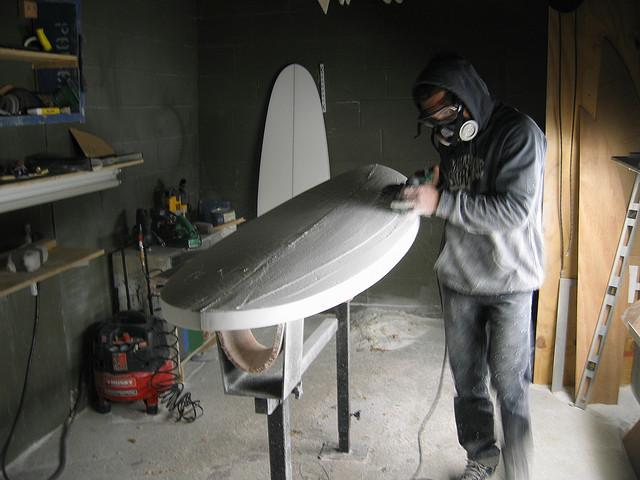What is on his face?
Answer briefly. Mask. What color is the table?
Quick response, please. White. What is the man making?
Concise answer only. Surfboard. 